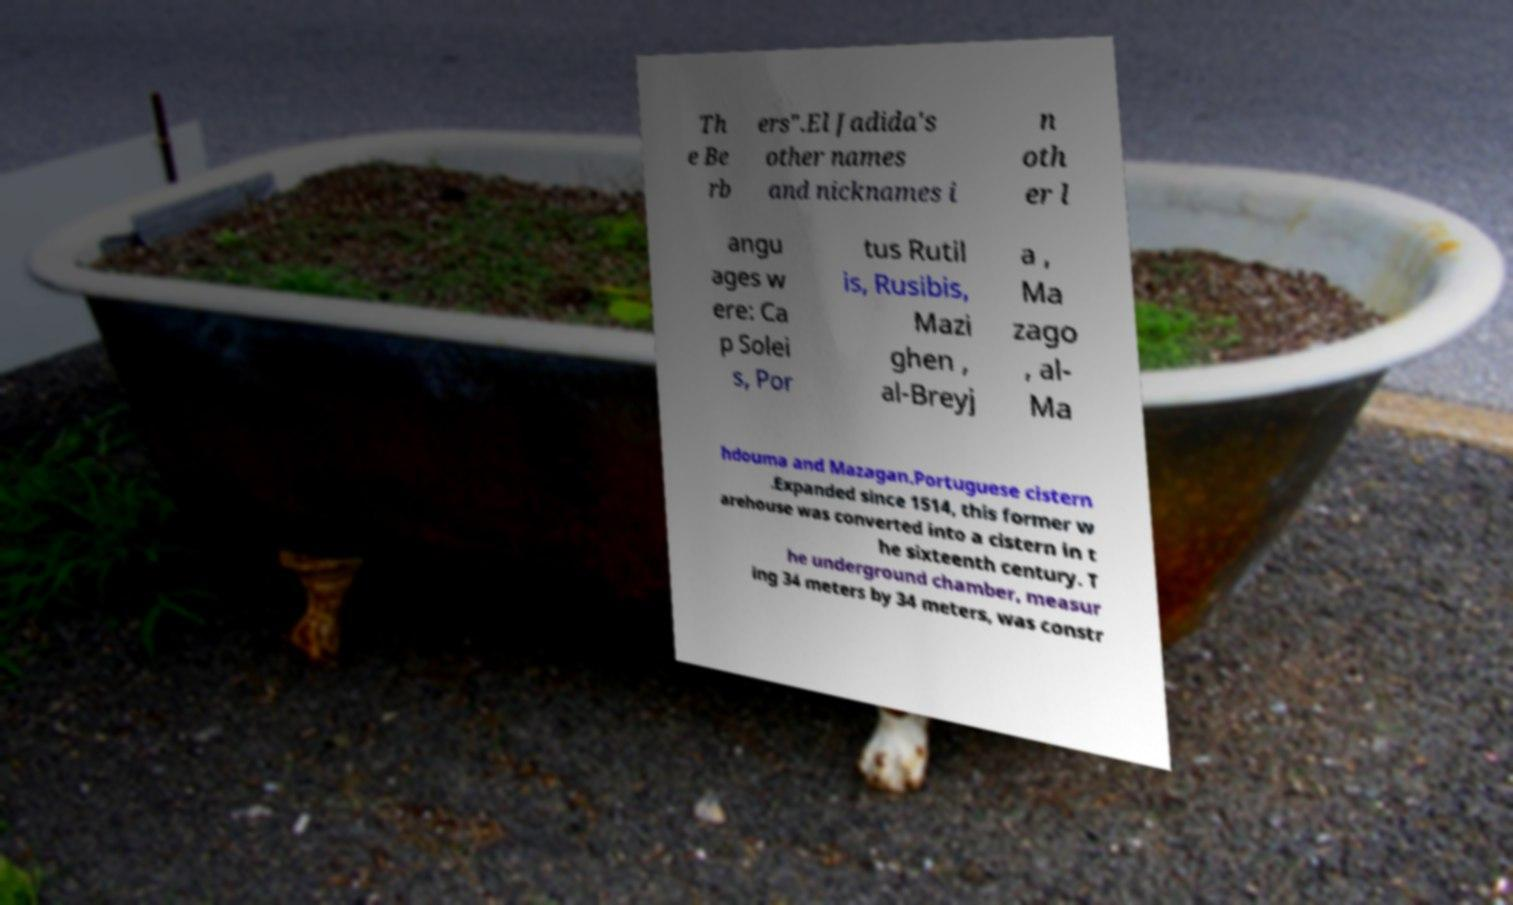What messages or text are displayed in this image? I need them in a readable, typed format. Th e Be rb ers".El Jadida's other names and nicknames i n oth er l angu ages w ere: Ca p Solei s, Por tus Rutil is, Rusibis, Mazi ghen , al-Breyj a , Ma zago , al- Ma hdouma and Mazagan.Portuguese cistern .Expanded since 1514, this former w arehouse was converted into a cistern in t he sixteenth century. T he underground chamber, measur ing 34 meters by 34 meters, was constr 